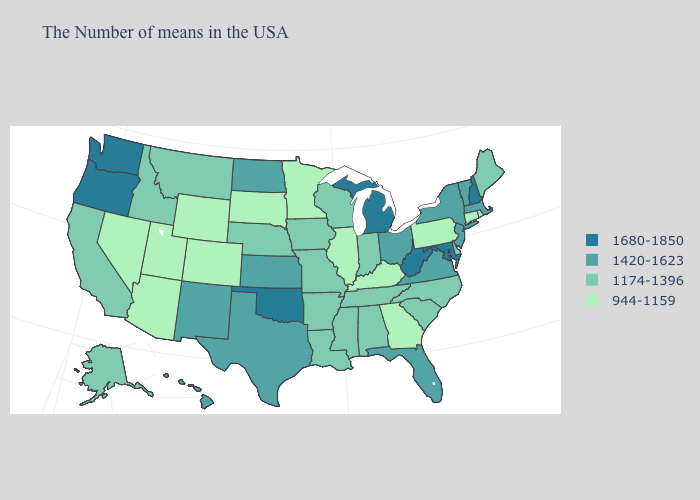What is the value of Arkansas?
Concise answer only. 1174-1396. Among the states that border Georgia , which have the highest value?
Short answer required. Florida. Among the states that border Missouri , which have the lowest value?
Answer briefly. Kentucky, Illinois. What is the lowest value in the Northeast?
Give a very brief answer. 944-1159. What is the value of New Hampshire?
Quick response, please. 1680-1850. Name the states that have a value in the range 944-1159?
Answer briefly. Rhode Island, Connecticut, Pennsylvania, Georgia, Kentucky, Illinois, Minnesota, South Dakota, Wyoming, Colorado, Utah, Arizona, Nevada. Name the states that have a value in the range 1680-1850?
Be succinct. New Hampshire, Maryland, West Virginia, Michigan, Oklahoma, Washington, Oregon. What is the highest value in the USA?
Concise answer only. 1680-1850. Which states have the lowest value in the USA?
Concise answer only. Rhode Island, Connecticut, Pennsylvania, Georgia, Kentucky, Illinois, Minnesota, South Dakota, Wyoming, Colorado, Utah, Arizona, Nevada. Does Florida have the lowest value in the South?
Short answer required. No. What is the value of Louisiana?
Give a very brief answer. 1174-1396. Name the states that have a value in the range 1680-1850?
Be succinct. New Hampshire, Maryland, West Virginia, Michigan, Oklahoma, Washington, Oregon. Does South Dakota have the lowest value in the USA?
Concise answer only. Yes. Does Washington have the highest value in the USA?
Keep it brief. Yes. What is the value of Idaho?
Write a very short answer. 1174-1396. 